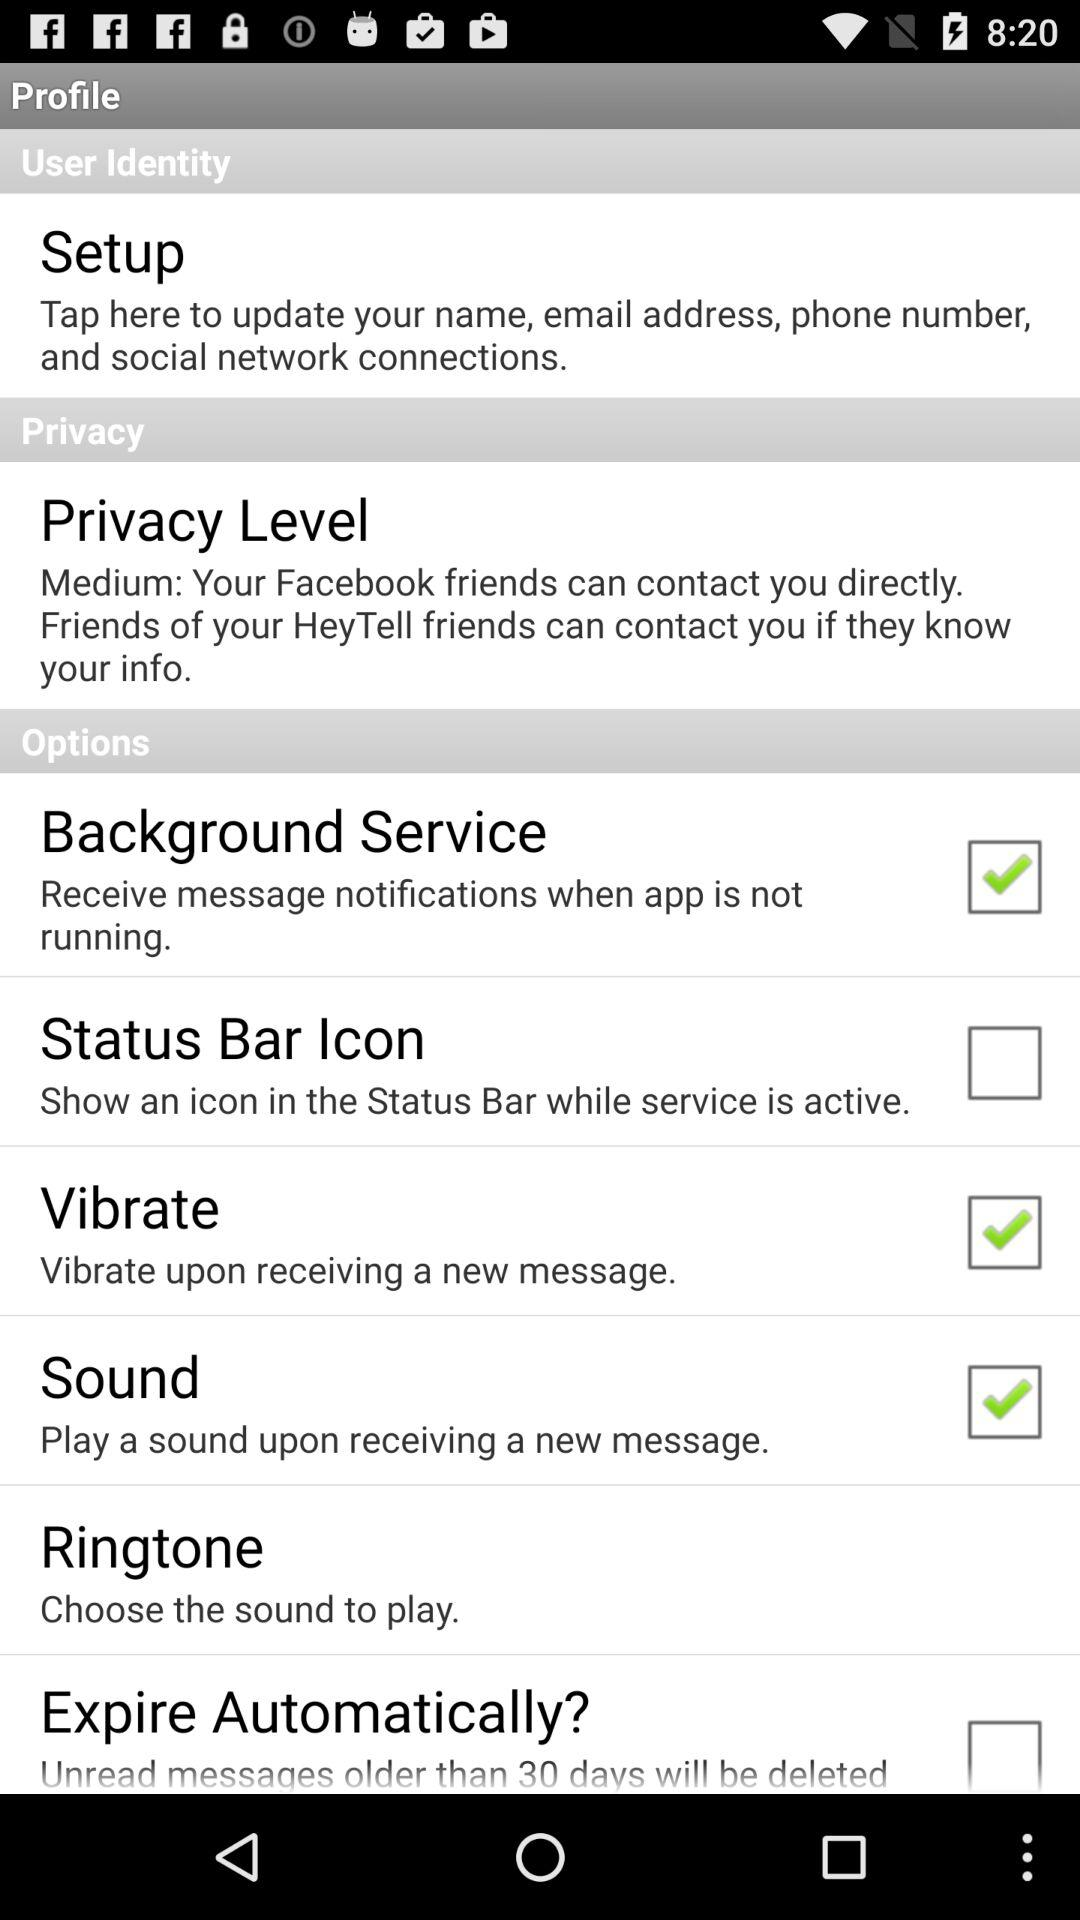What is the selected privacy level? The selected privacy level is "Medium". 